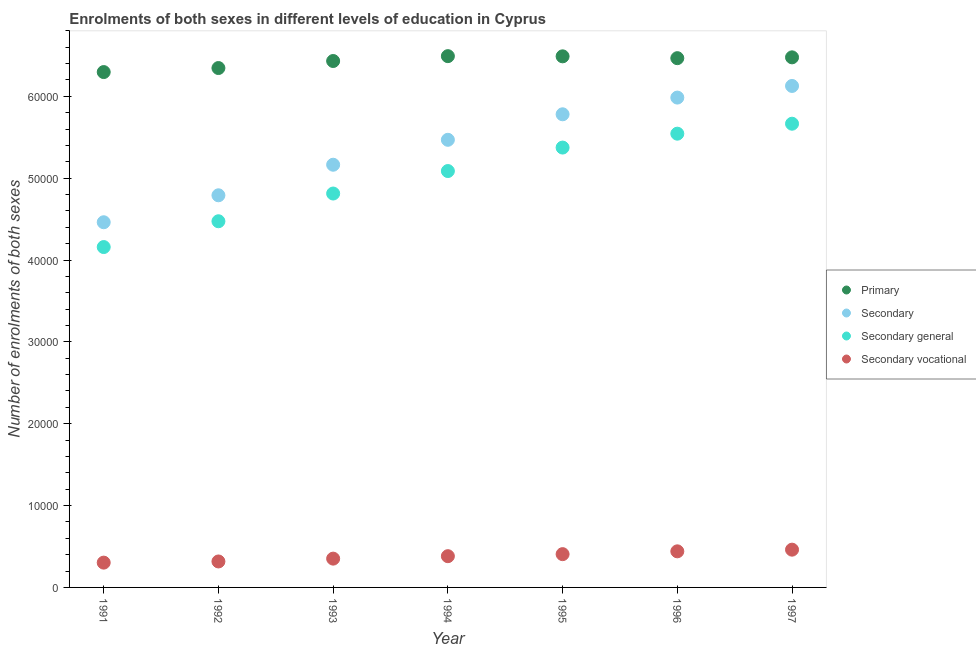What is the number of enrolments in secondary general education in 1996?
Your answer should be very brief. 5.54e+04. Across all years, what is the maximum number of enrolments in secondary vocational education?
Offer a terse response. 4614. Across all years, what is the minimum number of enrolments in secondary general education?
Make the answer very short. 4.16e+04. What is the total number of enrolments in secondary education in the graph?
Your response must be concise. 3.78e+05. What is the difference between the number of enrolments in secondary education in 1991 and that in 1992?
Give a very brief answer. -3294. What is the difference between the number of enrolments in secondary vocational education in 1994 and the number of enrolments in primary education in 1993?
Your answer should be compact. -6.05e+04. What is the average number of enrolments in primary education per year?
Provide a succinct answer. 6.43e+04. In the year 1997, what is the difference between the number of enrolments in primary education and number of enrolments in secondary vocational education?
Offer a terse response. 6.01e+04. In how many years, is the number of enrolments in secondary general education greater than 36000?
Provide a short and direct response. 7. What is the ratio of the number of enrolments in secondary general education in 1992 to that in 1994?
Offer a terse response. 0.88. Is the number of enrolments in primary education in 1995 less than that in 1997?
Your response must be concise. No. What is the difference between the highest and the second highest number of enrolments in secondary education?
Keep it short and to the point. 1421. What is the difference between the highest and the lowest number of enrolments in primary education?
Offer a terse response. 1945. In how many years, is the number of enrolments in primary education greater than the average number of enrolments in primary education taken over all years?
Offer a very short reply. 5. Is the sum of the number of enrolments in primary education in 1991 and 1992 greater than the maximum number of enrolments in secondary vocational education across all years?
Your answer should be compact. Yes. Is it the case that in every year, the sum of the number of enrolments in primary education and number of enrolments in secondary education is greater than the number of enrolments in secondary general education?
Keep it short and to the point. Yes. Is the number of enrolments in secondary vocational education strictly greater than the number of enrolments in primary education over the years?
Give a very brief answer. No. Is the number of enrolments in secondary education strictly less than the number of enrolments in primary education over the years?
Keep it short and to the point. Yes. What is the difference between two consecutive major ticks on the Y-axis?
Provide a short and direct response. 10000. Does the graph contain any zero values?
Your answer should be very brief. No. How are the legend labels stacked?
Provide a succinct answer. Vertical. What is the title of the graph?
Provide a succinct answer. Enrolments of both sexes in different levels of education in Cyprus. What is the label or title of the Y-axis?
Offer a very short reply. Number of enrolments of both sexes. What is the Number of enrolments of both sexes in Primary in 1991?
Offer a terse response. 6.30e+04. What is the Number of enrolments of both sexes in Secondary in 1991?
Your answer should be very brief. 4.46e+04. What is the Number of enrolments of both sexes of Secondary general in 1991?
Offer a very short reply. 4.16e+04. What is the Number of enrolments of both sexes of Secondary vocational in 1991?
Make the answer very short. 3030. What is the Number of enrolments of both sexes in Primary in 1992?
Offer a very short reply. 6.35e+04. What is the Number of enrolments of both sexes in Secondary in 1992?
Your answer should be compact. 4.79e+04. What is the Number of enrolments of both sexes in Secondary general in 1992?
Ensure brevity in your answer.  4.47e+04. What is the Number of enrolments of both sexes in Secondary vocational in 1992?
Your answer should be compact. 3172. What is the Number of enrolments of both sexes of Primary in 1993?
Offer a very short reply. 6.43e+04. What is the Number of enrolments of both sexes in Secondary in 1993?
Your answer should be compact. 5.16e+04. What is the Number of enrolments of both sexes in Secondary general in 1993?
Your answer should be very brief. 4.81e+04. What is the Number of enrolments of both sexes in Secondary vocational in 1993?
Ensure brevity in your answer.  3518. What is the Number of enrolments of both sexes in Primary in 1994?
Offer a terse response. 6.49e+04. What is the Number of enrolments of both sexes in Secondary in 1994?
Your response must be concise. 5.47e+04. What is the Number of enrolments of both sexes in Secondary general in 1994?
Offer a very short reply. 5.09e+04. What is the Number of enrolments of both sexes in Secondary vocational in 1994?
Your answer should be very brief. 3817. What is the Number of enrolments of both sexes in Primary in 1995?
Keep it short and to the point. 6.49e+04. What is the Number of enrolments of both sexes of Secondary in 1995?
Keep it short and to the point. 5.78e+04. What is the Number of enrolments of both sexes of Secondary general in 1995?
Your answer should be compact. 5.37e+04. What is the Number of enrolments of both sexes of Secondary vocational in 1995?
Offer a terse response. 4066. What is the Number of enrolments of both sexes in Primary in 1996?
Provide a short and direct response. 6.47e+04. What is the Number of enrolments of both sexes of Secondary in 1996?
Your answer should be very brief. 5.98e+04. What is the Number of enrolments of both sexes in Secondary general in 1996?
Keep it short and to the point. 5.54e+04. What is the Number of enrolments of both sexes of Secondary vocational in 1996?
Make the answer very short. 4410. What is the Number of enrolments of both sexes in Primary in 1997?
Provide a succinct answer. 6.48e+04. What is the Number of enrolments of both sexes in Secondary in 1997?
Your answer should be compact. 6.13e+04. What is the Number of enrolments of both sexes of Secondary general in 1997?
Your answer should be compact. 5.67e+04. What is the Number of enrolments of both sexes in Secondary vocational in 1997?
Your response must be concise. 4614. Across all years, what is the maximum Number of enrolments of both sexes in Primary?
Your answer should be compact. 6.49e+04. Across all years, what is the maximum Number of enrolments of both sexes in Secondary?
Offer a terse response. 6.13e+04. Across all years, what is the maximum Number of enrolments of both sexes in Secondary general?
Give a very brief answer. 5.67e+04. Across all years, what is the maximum Number of enrolments of both sexes in Secondary vocational?
Offer a very short reply. 4614. Across all years, what is the minimum Number of enrolments of both sexes of Primary?
Your response must be concise. 6.30e+04. Across all years, what is the minimum Number of enrolments of both sexes of Secondary?
Offer a very short reply. 4.46e+04. Across all years, what is the minimum Number of enrolments of both sexes in Secondary general?
Provide a short and direct response. 4.16e+04. Across all years, what is the minimum Number of enrolments of both sexes of Secondary vocational?
Provide a short and direct response. 3030. What is the total Number of enrolments of both sexes in Primary in the graph?
Ensure brevity in your answer.  4.50e+05. What is the total Number of enrolments of both sexes in Secondary in the graph?
Your response must be concise. 3.78e+05. What is the total Number of enrolments of both sexes of Secondary general in the graph?
Provide a succinct answer. 3.51e+05. What is the total Number of enrolments of both sexes of Secondary vocational in the graph?
Your answer should be compact. 2.66e+04. What is the difference between the Number of enrolments of both sexes in Primary in 1991 and that in 1992?
Make the answer very short. -492. What is the difference between the Number of enrolments of both sexes in Secondary in 1991 and that in 1992?
Keep it short and to the point. -3294. What is the difference between the Number of enrolments of both sexes in Secondary general in 1991 and that in 1992?
Make the answer very short. -3152. What is the difference between the Number of enrolments of both sexes of Secondary vocational in 1991 and that in 1992?
Keep it short and to the point. -142. What is the difference between the Number of enrolments of both sexes in Primary in 1991 and that in 1993?
Give a very brief answer. -1351. What is the difference between the Number of enrolments of both sexes in Secondary in 1991 and that in 1993?
Give a very brief answer. -7027. What is the difference between the Number of enrolments of both sexes in Secondary general in 1991 and that in 1993?
Ensure brevity in your answer.  -6539. What is the difference between the Number of enrolments of both sexes in Secondary vocational in 1991 and that in 1993?
Make the answer very short. -488. What is the difference between the Number of enrolments of both sexes in Primary in 1991 and that in 1994?
Give a very brief answer. -1945. What is the difference between the Number of enrolments of both sexes of Secondary in 1991 and that in 1994?
Your answer should be compact. -1.01e+04. What is the difference between the Number of enrolments of both sexes of Secondary general in 1991 and that in 1994?
Provide a succinct answer. -9286. What is the difference between the Number of enrolments of both sexes of Secondary vocational in 1991 and that in 1994?
Offer a very short reply. -787. What is the difference between the Number of enrolments of both sexes in Primary in 1991 and that in 1995?
Provide a succinct answer. -1922. What is the difference between the Number of enrolments of both sexes of Secondary in 1991 and that in 1995?
Keep it short and to the point. -1.32e+04. What is the difference between the Number of enrolments of both sexes in Secondary general in 1991 and that in 1995?
Offer a very short reply. -1.22e+04. What is the difference between the Number of enrolments of both sexes in Secondary vocational in 1991 and that in 1995?
Your response must be concise. -1036. What is the difference between the Number of enrolments of both sexes in Primary in 1991 and that in 1996?
Provide a short and direct response. -1698. What is the difference between the Number of enrolments of both sexes of Secondary in 1991 and that in 1996?
Your answer should be very brief. -1.52e+04. What is the difference between the Number of enrolments of both sexes of Secondary general in 1991 and that in 1996?
Make the answer very short. -1.39e+04. What is the difference between the Number of enrolments of both sexes in Secondary vocational in 1991 and that in 1996?
Ensure brevity in your answer.  -1380. What is the difference between the Number of enrolments of both sexes of Primary in 1991 and that in 1997?
Offer a very short reply. -1799. What is the difference between the Number of enrolments of both sexes of Secondary in 1991 and that in 1997?
Make the answer very short. -1.67e+04. What is the difference between the Number of enrolments of both sexes in Secondary general in 1991 and that in 1997?
Give a very brief answer. -1.51e+04. What is the difference between the Number of enrolments of both sexes in Secondary vocational in 1991 and that in 1997?
Provide a short and direct response. -1584. What is the difference between the Number of enrolments of both sexes of Primary in 1992 and that in 1993?
Your answer should be compact. -859. What is the difference between the Number of enrolments of both sexes in Secondary in 1992 and that in 1993?
Provide a short and direct response. -3733. What is the difference between the Number of enrolments of both sexes in Secondary general in 1992 and that in 1993?
Ensure brevity in your answer.  -3387. What is the difference between the Number of enrolments of both sexes of Secondary vocational in 1992 and that in 1993?
Provide a short and direct response. -346. What is the difference between the Number of enrolments of both sexes of Primary in 1992 and that in 1994?
Make the answer very short. -1453. What is the difference between the Number of enrolments of both sexes of Secondary in 1992 and that in 1994?
Provide a short and direct response. -6779. What is the difference between the Number of enrolments of both sexes in Secondary general in 1992 and that in 1994?
Ensure brevity in your answer.  -6134. What is the difference between the Number of enrolments of both sexes of Secondary vocational in 1992 and that in 1994?
Provide a succinct answer. -645. What is the difference between the Number of enrolments of both sexes in Primary in 1992 and that in 1995?
Offer a very short reply. -1430. What is the difference between the Number of enrolments of both sexes of Secondary in 1992 and that in 1995?
Your answer should be compact. -9896. What is the difference between the Number of enrolments of both sexes of Secondary general in 1992 and that in 1995?
Ensure brevity in your answer.  -9002. What is the difference between the Number of enrolments of both sexes of Secondary vocational in 1992 and that in 1995?
Your response must be concise. -894. What is the difference between the Number of enrolments of both sexes in Primary in 1992 and that in 1996?
Your answer should be compact. -1206. What is the difference between the Number of enrolments of both sexes of Secondary in 1992 and that in 1996?
Ensure brevity in your answer.  -1.19e+04. What is the difference between the Number of enrolments of both sexes in Secondary general in 1992 and that in 1996?
Your response must be concise. -1.07e+04. What is the difference between the Number of enrolments of both sexes in Secondary vocational in 1992 and that in 1996?
Provide a short and direct response. -1238. What is the difference between the Number of enrolments of both sexes of Primary in 1992 and that in 1997?
Make the answer very short. -1307. What is the difference between the Number of enrolments of both sexes in Secondary in 1992 and that in 1997?
Your answer should be compact. -1.34e+04. What is the difference between the Number of enrolments of both sexes of Secondary general in 1992 and that in 1997?
Ensure brevity in your answer.  -1.19e+04. What is the difference between the Number of enrolments of both sexes of Secondary vocational in 1992 and that in 1997?
Provide a short and direct response. -1442. What is the difference between the Number of enrolments of both sexes of Primary in 1993 and that in 1994?
Provide a succinct answer. -594. What is the difference between the Number of enrolments of both sexes in Secondary in 1993 and that in 1994?
Give a very brief answer. -3046. What is the difference between the Number of enrolments of both sexes of Secondary general in 1993 and that in 1994?
Offer a terse response. -2747. What is the difference between the Number of enrolments of both sexes in Secondary vocational in 1993 and that in 1994?
Give a very brief answer. -299. What is the difference between the Number of enrolments of both sexes of Primary in 1993 and that in 1995?
Provide a succinct answer. -571. What is the difference between the Number of enrolments of both sexes of Secondary in 1993 and that in 1995?
Your response must be concise. -6163. What is the difference between the Number of enrolments of both sexes of Secondary general in 1993 and that in 1995?
Give a very brief answer. -5615. What is the difference between the Number of enrolments of both sexes in Secondary vocational in 1993 and that in 1995?
Your response must be concise. -548. What is the difference between the Number of enrolments of both sexes in Primary in 1993 and that in 1996?
Give a very brief answer. -347. What is the difference between the Number of enrolments of both sexes in Secondary in 1993 and that in 1996?
Your answer should be compact. -8204. What is the difference between the Number of enrolments of both sexes in Secondary general in 1993 and that in 1996?
Offer a terse response. -7312. What is the difference between the Number of enrolments of both sexes of Secondary vocational in 1993 and that in 1996?
Your answer should be very brief. -892. What is the difference between the Number of enrolments of both sexes of Primary in 1993 and that in 1997?
Provide a succinct answer. -448. What is the difference between the Number of enrolments of both sexes in Secondary in 1993 and that in 1997?
Give a very brief answer. -9625. What is the difference between the Number of enrolments of both sexes of Secondary general in 1993 and that in 1997?
Your answer should be compact. -8529. What is the difference between the Number of enrolments of both sexes of Secondary vocational in 1993 and that in 1997?
Ensure brevity in your answer.  -1096. What is the difference between the Number of enrolments of both sexes in Primary in 1994 and that in 1995?
Provide a short and direct response. 23. What is the difference between the Number of enrolments of both sexes of Secondary in 1994 and that in 1995?
Give a very brief answer. -3117. What is the difference between the Number of enrolments of both sexes in Secondary general in 1994 and that in 1995?
Keep it short and to the point. -2868. What is the difference between the Number of enrolments of both sexes of Secondary vocational in 1994 and that in 1995?
Offer a very short reply. -249. What is the difference between the Number of enrolments of both sexes in Primary in 1994 and that in 1996?
Make the answer very short. 247. What is the difference between the Number of enrolments of both sexes in Secondary in 1994 and that in 1996?
Give a very brief answer. -5158. What is the difference between the Number of enrolments of both sexes of Secondary general in 1994 and that in 1996?
Provide a succinct answer. -4565. What is the difference between the Number of enrolments of both sexes in Secondary vocational in 1994 and that in 1996?
Offer a terse response. -593. What is the difference between the Number of enrolments of both sexes of Primary in 1994 and that in 1997?
Provide a succinct answer. 146. What is the difference between the Number of enrolments of both sexes in Secondary in 1994 and that in 1997?
Your answer should be compact. -6579. What is the difference between the Number of enrolments of both sexes of Secondary general in 1994 and that in 1997?
Your response must be concise. -5782. What is the difference between the Number of enrolments of both sexes in Secondary vocational in 1994 and that in 1997?
Provide a short and direct response. -797. What is the difference between the Number of enrolments of both sexes of Primary in 1995 and that in 1996?
Offer a terse response. 224. What is the difference between the Number of enrolments of both sexes in Secondary in 1995 and that in 1996?
Your response must be concise. -2041. What is the difference between the Number of enrolments of both sexes of Secondary general in 1995 and that in 1996?
Your answer should be very brief. -1697. What is the difference between the Number of enrolments of both sexes in Secondary vocational in 1995 and that in 1996?
Give a very brief answer. -344. What is the difference between the Number of enrolments of both sexes in Primary in 1995 and that in 1997?
Your answer should be very brief. 123. What is the difference between the Number of enrolments of both sexes of Secondary in 1995 and that in 1997?
Provide a short and direct response. -3462. What is the difference between the Number of enrolments of both sexes of Secondary general in 1995 and that in 1997?
Your response must be concise. -2914. What is the difference between the Number of enrolments of both sexes in Secondary vocational in 1995 and that in 1997?
Provide a succinct answer. -548. What is the difference between the Number of enrolments of both sexes in Primary in 1996 and that in 1997?
Keep it short and to the point. -101. What is the difference between the Number of enrolments of both sexes of Secondary in 1996 and that in 1997?
Provide a succinct answer. -1421. What is the difference between the Number of enrolments of both sexes in Secondary general in 1996 and that in 1997?
Provide a succinct answer. -1217. What is the difference between the Number of enrolments of both sexes in Secondary vocational in 1996 and that in 1997?
Offer a very short reply. -204. What is the difference between the Number of enrolments of both sexes in Primary in 1991 and the Number of enrolments of both sexes in Secondary in 1992?
Your response must be concise. 1.51e+04. What is the difference between the Number of enrolments of both sexes in Primary in 1991 and the Number of enrolments of both sexes in Secondary general in 1992?
Offer a very short reply. 1.82e+04. What is the difference between the Number of enrolments of both sexes in Primary in 1991 and the Number of enrolments of both sexes in Secondary vocational in 1992?
Your answer should be compact. 5.98e+04. What is the difference between the Number of enrolments of both sexes in Secondary in 1991 and the Number of enrolments of both sexes in Secondary general in 1992?
Your response must be concise. -122. What is the difference between the Number of enrolments of both sexes of Secondary in 1991 and the Number of enrolments of both sexes of Secondary vocational in 1992?
Your response must be concise. 4.14e+04. What is the difference between the Number of enrolments of both sexes in Secondary general in 1991 and the Number of enrolments of both sexes in Secondary vocational in 1992?
Your answer should be very brief. 3.84e+04. What is the difference between the Number of enrolments of both sexes in Primary in 1991 and the Number of enrolments of both sexes in Secondary in 1993?
Ensure brevity in your answer.  1.13e+04. What is the difference between the Number of enrolments of both sexes of Primary in 1991 and the Number of enrolments of both sexes of Secondary general in 1993?
Ensure brevity in your answer.  1.48e+04. What is the difference between the Number of enrolments of both sexes of Primary in 1991 and the Number of enrolments of both sexes of Secondary vocational in 1993?
Offer a very short reply. 5.94e+04. What is the difference between the Number of enrolments of both sexes of Secondary in 1991 and the Number of enrolments of both sexes of Secondary general in 1993?
Your answer should be very brief. -3509. What is the difference between the Number of enrolments of both sexes in Secondary in 1991 and the Number of enrolments of both sexes in Secondary vocational in 1993?
Keep it short and to the point. 4.11e+04. What is the difference between the Number of enrolments of both sexes in Secondary general in 1991 and the Number of enrolments of both sexes in Secondary vocational in 1993?
Provide a short and direct response. 3.81e+04. What is the difference between the Number of enrolments of both sexes in Primary in 1991 and the Number of enrolments of both sexes in Secondary in 1994?
Your answer should be compact. 8275. What is the difference between the Number of enrolments of both sexes in Primary in 1991 and the Number of enrolments of both sexes in Secondary general in 1994?
Keep it short and to the point. 1.21e+04. What is the difference between the Number of enrolments of both sexes in Primary in 1991 and the Number of enrolments of both sexes in Secondary vocational in 1994?
Offer a very short reply. 5.91e+04. What is the difference between the Number of enrolments of both sexes in Secondary in 1991 and the Number of enrolments of both sexes in Secondary general in 1994?
Give a very brief answer. -6256. What is the difference between the Number of enrolments of both sexes of Secondary in 1991 and the Number of enrolments of both sexes of Secondary vocational in 1994?
Provide a short and direct response. 4.08e+04. What is the difference between the Number of enrolments of both sexes in Secondary general in 1991 and the Number of enrolments of both sexes in Secondary vocational in 1994?
Your answer should be very brief. 3.78e+04. What is the difference between the Number of enrolments of both sexes in Primary in 1991 and the Number of enrolments of both sexes in Secondary in 1995?
Your response must be concise. 5158. What is the difference between the Number of enrolments of both sexes in Primary in 1991 and the Number of enrolments of both sexes in Secondary general in 1995?
Your response must be concise. 9224. What is the difference between the Number of enrolments of both sexes in Primary in 1991 and the Number of enrolments of both sexes in Secondary vocational in 1995?
Make the answer very short. 5.89e+04. What is the difference between the Number of enrolments of both sexes in Secondary in 1991 and the Number of enrolments of both sexes in Secondary general in 1995?
Offer a very short reply. -9124. What is the difference between the Number of enrolments of both sexes of Secondary in 1991 and the Number of enrolments of both sexes of Secondary vocational in 1995?
Make the answer very short. 4.05e+04. What is the difference between the Number of enrolments of both sexes of Secondary general in 1991 and the Number of enrolments of both sexes of Secondary vocational in 1995?
Your response must be concise. 3.75e+04. What is the difference between the Number of enrolments of both sexes of Primary in 1991 and the Number of enrolments of both sexes of Secondary in 1996?
Provide a succinct answer. 3117. What is the difference between the Number of enrolments of both sexes of Primary in 1991 and the Number of enrolments of both sexes of Secondary general in 1996?
Provide a succinct answer. 7527. What is the difference between the Number of enrolments of both sexes of Primary in 1991 and the Number of enrolments of both sexes of Secondary vocational in 1996?
Give a very brief answer. 5.86e+04. What is the difference between the Number of enrolments of both sexes of Secondary in 1991 and the Number of enrolments of both sexes of Secondary general in 1996?
Provide a short and direct response. -1.08e+04. What is the difference between the Number of enrolments of both sexes of Secondary in 1991 and the Number of enrolments of both sexes of Secondary vocational in 1996?
Give a very brief answer. 4.02e+04. What is the difference between the Number of enrolments of both sexes of Secondary general in 1991 and the Number of enrolments of both sexes of Secondary vocational in 1996?
Keep it short and to the point. 3.72e+04. What is the difference between the Number of enrolments of both sexes in Primary in 1991 and the Number of enrolments of both sexes in Secondary in 1997?
Offer a very short reply. 1696. What is the difference between the Number of enrolments of both sexes of Primary in 1991 and the Number of enrolments of both sexes of Secondary general in 1997?
Keep it short and to the point. 6310. What is the difference between the Number of enrolments of both sexes of Primary in 1991 and the Number of enrolments of both sexes of Secondary vocational in 1997?
Provide a succinct answer. 5.83e+04. What is the difference between the Number of enrolments of both sexes in Secondary in 1991 and the Number of enrolments of both sexes in Secondary general in 1997?
Give a very brief answer. -1.20e+04. What is the difference between the Number of enrolments of both sexes in Secondary general in 1991 and the Number of enrolments of both sexes in Secondary vocational in 1997?
Keep it short and to the point. 3.70e+04. What is the difference between the Number of enrolments of both sexes in Primary in 1992 and the Number of enrolments of both sexes in Secondary in 1993?
Give a very brief answer. 1.18e+04. What is the difference between the Number of enrolments of both sexes in Primary in 1992 and the Number of enrolments of both sexes in Secondary general in 1993?
Your response must be concise. 1.53e+04. What is the difference between the Number of enrolments of both sexes in Primary in 1992 and the Number of enrolments of both sexes in Secondary vocational in 1993?
Offer a very short reply. 5.99e+04. What is the difference between the Number of enrolments of both sexes in Secondary in 1992 and the Number of enrolments of both sexes in Secondary general in 1993?
Keep it short and to the point. -215. What is the difference between the Number of enrolments of both sexes in Secondary in 1992 and the Number of enrolments of both sexes in Secondary vocational in 1993?
Make the answer very short. 4.44e+04. What is the difference between the Number of enrolments of both sexes in Secondary general in 1992 and the Number of enrolments of both sexes in Secondary vocational in 1993?
Give a very brief answer. 4.12e+04. What is the difference between the Number of enrolments of both sexes in Primary in 1992 and the Number of enrolments of both sexes in Secondary in 1994?
Your answer should be compact. 8767. What is the difference between the Number of enrolments of both sexes in Primary in 1992 and the Number of enrolments of both sexes in Secondary general in 1994?
Give a very brief answer. 1.26e+04. What is the difference between the Number of enrolments of both sexes of Primary in 1992 and the Number of enrolments of both sexes of Secondary vocational in 1994?
Keep it short and to the point. 5.96e+04. What is the difference between the Number of enrolments of both sexes in Secondary in 1992 and the Number of enrolments of both sexes in Secondary general in 1994?
Provide a short and direct response. -2962. What is the difference between the Number of enrolments of both sexes of Secondary in 1992 and the Number of enrolments of both sexes of Secondary vocational in 1994?
Make the answer very short. 4.41e+04. What is the difference between the Number of enrolments of both sexes of Secondary general in 1992 and the Number of enrolments of both sexes of Secondary vocational in 1994?
Ensure brevity in your answer.  4.09e+04. What is the difference between the Number of enrolments of both sexes in Primary in 1992 and the Number of enrolments of both sexes in Secondary in 1995?
Offer a terse response. 5650. What is the difference between the Number of enrolments of both sexes of Primary in 1992 and the Number of enrolments of both sexes of Secondary general in 1995?
Make the answer very short. 9716. What is the difference between the Number of enrolments of both sexes in Primary in 1992 and the Number of enrolments of both sexes in Secondary vocational in 1995?
Give a very brief answer. 5.94e+04. What is the difference between the Number of enrolments of both sexes in Secondary in 1992 and the Number of enrolments of both sexes in Secondary general in 1995?
Provide a short and direct response. -5830. What is the difference between the Number of enrolments of both sexes of Secondary in 1992 and the Number of enrolments of both sexes of Secondary vocational in 1995?
Provide a short and direct response. 4.38e+04. What is the difference between the Number of enrolments of both sexes of Secondary general in 1992 and the Number of enrolments of both sexes of Secondary vocational in 1995?
Your answer should be very brief. 4.07e+04. What is the difference between the Number of enrolments of both sexes in Primary in 1992 and the Number of enrolments of both sexes in Secondary in 1996?
Keep it short and to the point. 3609. What is the difference between the Number of enrolments of both sexes in Primary in 1992 and the Number of enrolments of both sexes in Secondary general in 1996?
Give a very brief answer. 8019. What is the difference between the Number of enrolments of both sexes in Primary in 1992 and the Number of enrolments of both sexes in Secondary vocational in 1996?
Offer a very short reply. 5.90e+04. What is the difference between the Number of enrolments of both sexes of Secondary in 1992 and the Number of enrolments of both sexes of Secondary general in 1996?
Keep it short and to the point. -7527. What is the difference between the Number of enrolments of both sexes in Secondary in 1992 and the Number of enrolments of both sexes in Secondary vocational in 1996?
Your answer should be very brief. 4.35e+04. What is the difference between the Number of enrolments of both sexes of Secondary general in 1992 and the Number of enrolments of both sexes of Secondary vocational in 1996?
Your response must be concise. 4.03e+04. What is the difference between the Number of enrolments of both sexes in Primary in 1992 and the Number of enrolments of both sexes in Secondary in 1997?
Make the answer very short. 2188. What is the difference between the Number of enrolments of both sexes of Primary in 1992 and the Number of enrolments of both sexes of Secondary general in 1997?
Your answer should be very brief. 6802. What is the difference between the Number of enrolments of both sexes in Primary in 1992 and the Number of enrolments of both sexes in Secondary vocational in 1997?
Offer a terse response. 5.88e+04. What is the difference between the Number of enrolments of both sexes of Secondary in 1992 and the Number of enrolments of both sexes of Secondary general in 1997?
Provide a short and direct response. -8744. What is the difference between the Number of enrolments of both sexes in Secondary in 1992 and the Number of enrolments of both sexes in Secondary vocational in 1997?
Give a very brief answer. 4.33e+04. What is the difference between the Number of enrolments of both sexes in Secondary general in 1992 and the Number of enrolments of both sexes in Secondary vocational in 1997?
Your answer should be very brief. 4.01e+04. What is the difference between the Number of enrolments of both sexes of Primary in 1993 and the Number of enrolments of both sexes of Secondary in 1994?
Your answer should be very brief. 9626. What is the difference between the Number of enrolments of both sexes of Primary in 1993 and the Number of enrolments of both sexes of Secondary general in 1994?
Provide a succinct answer. 1.34e+04. What is the difference between the Number of enrolments of both sexes of Primary in 1993 and the Number of enrolments of both sexes of Secondary vocational in 1994?
Make the answer very short. 6.05e+04. What is the difference between the Number of enrolments of both sexes of Secondary in 1993 and the Number of enrolments of both sexes of Secondary general in 1994?
Keep it short and to the point. 771. What is the difference between the Number of enrolments of both sexes in Secondary in 1993 and the Number of enrolments of both sexes in Secondary vocational in 1994?
Keep it short and to the point. 4.78e+04. What is the difference between the Number of enrolments of both sexes in Secondary general in 1993 and the Number of enrolments of both sexes in Secondary vocational in 1994?
Offer a terse response. 4.43e+04. What is the difference between the Number of enrolments of both sexes of Primary in 1993 and the Number of enrolments of both sexes of Secondary in 1995?
Your response must be concise. 6509. What is the difference between the Number of enrolments of both sexes of Primary in 1993 and the Number of enrolments of both sexes of Secondary general in 1995?
Your response must be concise. 1.06e+04. What is the difference between the Number of enrolments of both sexes of Primary in 1993 and the Number of enrolments of both sexes of Secondary vocational in 1995?
Offer a very short reply. 6.02e+04. What is the difference between the Number of enrolments of both sexes of Secondary in 1993 and the Number of enrolments of both sexes of Secondary general in 1995?
Ensure brevity in your answer.  -2097. What is the difference between the Number of enrolments of both sexes in Secondary in 1993 and the Number of enrolments of both sexes in Secondary vocational in 1995?
Provide a short and direct response. 4.76e+04. What is the difference between the Number of enrolments of both sexes in Secondary general in 1993 and the Number of enrolments of both sexes in Secondary vocational in 1995?
Keep it short and to the point. 4.41e+04. What is the difference between the Number of enrolments of both sexes in Primary in 1993 and the Number of enrolments of both sexes in Secondary in 1996?
Your answer should be very brief. 4468. What is the difference between the Number of enrolments of both sexes in Primary in 1993 and the Number of enrolments of both sexes in Secondary general in 1996?
Provide a succinct answer. 8878. What is the difference between the Number of enrolments of both sexes in Primary in 1993 and the Number of enrolments of both sexes in Secondary vocational in 1996?
Offer a very short reply. 5.99e+04. What is the difference between the Number of enrolments of both sexes in Secondary in 1993 and the Number of enrolments of both sexes in Secondary general in 1996?
Make the answer very short. -3794. What is the difference between the Number of enrolments of both sexes of Secondary in 1993 and the Number of enrolments of both sexes of Secondary vocational in 1996?
Keep it short and to the point. 4.72e+04. What is the difference between the Number of enrolments of both sexes of Secondary general in 1993 and the Number of enrolments of both sexes of Secondary vocational in 1996?
Make the answer very short. 4.37e+04. What is the difference between the Number of enrolments of both sexes in Primary in 1993 and the Number of enrolments of both sexes in Secondary in 1997?
Provide a short and direct response. 3047. What is the difference between the Number of enrolments of both sexes of Primary in 1993 and the Number of enrolments of both sexes of Secondary general in 1997?
Offer a terse response. 7661. What is the difference between the Number of enrolments of both sexes in Primary in 1993 and the Number of enrolments of both sexes in Secondary vocational in 1997?
Give a very brief answer. 5.97e+04. What is the difference between the Number of enrolments of both sexes of Secondary in 1993 and the Number of enrolments of both sexes of Secondary general in 1997?
Offer a terse response. -5011. What is the difference between the Number of enrolments of both sexes in Secondary in 1993 and the Number of enrolments of both sexes in Secondary vocational in 1997?
Keep it short and to the point. 4.70e+04. What is the difference between the Number of enrolments of both sexes in Secondary general in 1993 and the Number of enrolments of both sexes in Secondary vocational in 1997?
Give a very brief answer. 4.35e+04. What is the difference between the Number of enrolments of both sexes of Primary in 1994 and the Number of enrolments of both sexes of Secondary in 1995?
Your response must be concise. 7103. What is the difference between the Number of enrolments of both sexes in Primary in 1994 and the Number of enrolments of both sexes in Secondary general in 1995?
Your response must be concise. 1.12e+04. What is the difference between the Number of enrolments of both sexes of Primary in 1994 and the Number of enrolments of both sexes of Secondary vocational in 1995?
Offer a very short reply. 6.08e+04. What is the difference between the Number of enrolments of both sexes of Secondary in 1994 and the Number of enrolments of both sexes of Secondary general in 1995?
Give a very brief answer. 949. What is the difference between the Number of enrolments of both sexes in Secondary in 1994 and the Number of enrolments of both sexes in Secondary vocational in 1995?
Your answer should be compact. 5.06e+04. What is the difference between the Number of enrolments of both sexes of Secondary general in 1994 and the Number of enrolments of both sexes of Secondary vocational in 1995?
Your response must be concise. 4.68e+04. What is the difference between the Number of enrolments of both sexes of Primary in 1994 and the Number of enrolments of both sexes of Secondary in 1996?
Offer a terse response. 5062. What is the difference between the Number of enrolments of both sexes in Primary in 1994 and the Number of enrolments of both sexes in Secondary general in 1996?
Make the answer very short. 9472. What is the difference between the Number of enrolments of both sexes in Primary in 1994 and the Number of enrolments of both sexes in Secondary vocational in 1996?
Keep it short and to the point. 6.05e+04. What is the difference between the Number of enrolments of both sexes of Secondary in 1994 and the Number of enrolments of both sexes of Secondary general in 1996?
Make the answer very short. -748. What is the difference between the Number of enrolments of both sexes in Secondary in 1994 and the Number of enrolments of both sexes in Secondary vocational in 1996?
Ensure brevity in your answer.  5.03e+04. What is the difference between the Number of enrolments of both sexes of Secondary general in 1994 and the Number of enrolments of both sexes of Secondary vocational in 1996?
Your answer should be very brief. 4.65e+04. What is the difference between the Number of enrolments of both sexes of Primary in 1994 and the Number of enrolments of both sexes of Secondary in 1997?
Provide a short and direct response. 3641. What is the difference between the Number of enrolments of both sexes of Primary in 1994 and the Number of enrolments of both sexes of Secondary general in 1997?
Provide a short and direct response. 8255. What is the difference between the Number of enrolments of both sexes in Primary in 1994 and the Number of enrolments of both sexes in Secondary vocational in 1997?
Give a very brief answer. 6.03e+04. What is the difference between the Number of enrolments of both sexes in Secondary in 1994 and the Number of enrolments of both sexes in Secondary general in 1997?
Ensure brevity in your answer.  -1965. What is the difference between the Number of enrolments of both sexes in Secondary in 1994 and the Number of enrolments of both sexes in Secondary vocational in 1997?
Keep it short and to the point. 5.01e+04. What is the difference between the Number of enrolments of both sexes in Secondary general in 1994 and the Number of enrolments of both sexes in Secondary vocational in 1997?
Give a very brief answer. 4.63e+04. What is the difference between the Number of enrolments of both sexes of Primary in 1995 and the Number of enrolments of both sexes of Secondary in 1996?
Give a very brief answer. 5039. What is the difference between the Number of enrolments of both sexes of Primary in 1995 and the Number of enrolments of both sexes of Secondary general in 1996?
Your answer should be very brief. 9449. What is the difference between the Number of enrolments of both sexes in Primary in 1995 and the Number of enrolments of both sexes in Secondary vocational in 1996?
Give a very brief answer. 6.05e+04. What is the difference between the Number of enrolments of both sexes in Secondary in 1995 and the Number of enrolments of both sexes in Secondary general in 1996?
Provide a succinct answer. 2369. What is the difference between the Number of enrolments of both sexes of Secondary in 1995 and the Number of enrolments of both sexes of Secondary vocational in 1996?
Ensure brevity in your answer.  5.34e+04. What is the difference between the Number of enrolments of both sexes of Secondary general in 1995 and the Number of enrolments of both sexes of Secondary vocational in 1996?
Give a very brief answer. 4.93e+04. What is the difference between the Number of enrolments of both sexes in Primary in 1995 and the Number of enrolments of both sexes in Secondary in 1997?
Provide a succinct answer. 3618. What is the difference between the Number of enrolments of both sexes in Primary in 1995 and the Number of enrolments of both sexes in Secondary general in 1997?
Give a very brief answer. 8232. What is the difference between the Number of enrolments of both sexes in Primary in 1995 and the Number of enrolments of both sexes in Secondary vocational in 1997?
Make the answer very short. 6.03e+04. What is the difference between the Number of enrolments of both sexes in Secondary in 1995 and the Number of enrolments of both sexes in Secondary general in 1997?
Your answer should be compact. 1152. What is the difference between the Number of enrolments of both sexes of Secondary in 1995 and the Number of enrolments of both sexes of Secondary vocational in 1997?
Offer a terse response. 5.32e+04. What is the difference between the Number of enrolments of both sexes in Secondary general in 1995 and the Number of enrolments of both sexes in Secondary vocational in 1997?
Your answer should be very brief. 4.91e+04. What is the difference between the Number of enrolments of both sexes of Primary in 1996 and the Number of enrolments of both sexes of Secondary in 1997?
Offer a very short reply. 3394. What is the difference between the Number of enrolments of both sexes in Primary in 1996 and the Number of enrolments of both sexes in Secondary general in 1997?
Your answer should be compact. 8008. What is the difference between the Number of enrolments of both sexes of Primary in 1996 and the Number of enrolments of both sexes of Secondary vocational in 1997?
Offer a very short reply. 6.00e+04. What is the difference between the Number of enrolments of both sexes of Secondary in 1996 and the Number of enrolments of both sexes of Secondary general in 1997?
Make the answer very short. 3193. What is the difference between the Number of enrolments of both sexes of Secondary in 1996 and the Number of enrolments of both sexes of Secondary vocational in 1997?
Keep it short and to the point. 5.52e+04. What is the difference between the Number of enrolments of both sexes in Secondary general in 1996 and the Number of enrolments of both sexes in Secondary vocational in 1997?
Ensure brevity in your answer.  5.08e+04. What is the average Number of enrolments of both sexes of Primary per year?
Provide a short and direct response. 6.43e+04. What is the average Number of enrolments of both sexes of Secondary per year?
Ensure brevity in your answer.  5.40e+04. What is the average Number of enrolments of both sexes of Secondary general per year?
Keep it short and to the point. 5.02e+04. What is the average Number of enrolments of both sexes of Secondary vocational per year?
Your response must be concise. 3803.86. In the year 1991, what is the difference between the Number of enrolments of both sexes in Primary and Number of enrolments of both sexes in Secondary?
Keep it short and to the point. 1.83e+04. In the year 1991, what is the difference between the Number of enrolments of both sexes in Primary and Number of enrolments of both sexes in Secondary general?
Provide a succinct answer. 2.14e+04. In the year 1991, what is the difference between the Number of enrolments of both sexes in Primary and Number of enrolments of both sexes in Secondary vocational?
Make the answer very short. 5.99e+04. In the year 1991, what is the difference between the Number of enrolments of both sexes in Secondary and Number of enrolments of both sexes in Secondary general?
Your response must be concise. 3030. In the year 1991, what is the difference between the Number of enrolments of both sexes of Secondary and Number of enrolments of both sexes of Secondary vocational?
Your answer should be very brief. 4.16e+04. In the year 1991, what is the difference between the Number of enrolments of both sexes of Secondary general and Number of enrolments of both sexes of Secondary vocational?
Provide a succinct answer. 3.86e+04. In the year 1992, what is the difference between the Number of enrolments of both sexes in Primary and Number of enrolments of both sexes in Secondary?
Your answer should be very brief. 1.55e+04. In the year 1992, what is the difference between the Number of enrolments of both sexes in Primary and Number of enrolments of both sexes in Secondary general?
Make the answer very short. 1.87e+04. In the year 1992, what is the difference between the Number of enrolments of both sexes of Primary and Number of enrolments of both sexes of Secondary vocational?
Your answer should be compact. 6.03e+04. In the year 1992, what is the difference between the Number of enrolments of both sexes in Secondary and Number of enrolments of both sexes in Secondary general?
Make the answer very short. 3172. In the year 1992, what is the difference between the Number of enrolments of both sexes of Secondary and Number of enrolments of both sexes of Secondary vocational?
Make the answer very short. 4.47e+04. In the year 1992, what is the difference between the Number of enrolments of both sexes in Secondary general and Number of enrolments of both sexes in Secondary vocational?
Your answer should be very brief. 4.16e+04. In the year 1993, what is the difference between the Number of enrolments of both sexes in Primary and Number of enrolments of both sexes in Secondary?
Offer a very short reply. 1.27e+04. In the year 1993, what is the difference between the Number of enrolments of both sexes in Primary and Number of enrolments of both sexes in Secondary general?
Give a very brief answer. 1.62e+04. In the year 1993, what is the difference between the Number of enrolments of both sexes in Primary and Number of enrolments of both sexes in Secondary vocational?
Keep it short and to the point. 6.08e+04. In the year 1993, what is the difference between the Number of enrolments of both sexes of Secondary and Number of enrolments of both sexes of Secondary general?
Provide a short and direct response. 3518. In the year 1993, what is the difference between the Number of enrolments of both sexes in Secondary and Number of enrolments of both sexes in Secondary vocational?
Your answer should be compact. 4.81e+04. In the year 1993, what is the difference between the Number of enrolments of both sexes of Secondary general and Number of enrolments of both sexes of Secondary vocational?
Your response must be concise. 4.46e+04. In the year 1994, what is the difference between the Number of enrolments of both sexes in Primary and Number of enrolments of both sexes in Secondary?
Your answer should be compact. 1.02e+04. In the year 1994, what is the difference between the Number of enrolments of both sexes in Primary and Number of enrolments of both sexes in Secondary general?
Give a very brief answer. 1.40e+04. In the year 1994, what is the difference between the Number of enrolments of both sexes of Primary and Number of enrolments of both sexes of Secondary vocational?
Provide a short and direct response. 6.11e+04. In the year 1994, what is the difference between the Number of enrolments of both sexes of Secondary and Number of enrolments of both sexes of Secondary general?
Give a very brief answer. 3817. In the year 1994, what is the difference between the Number of enrolments of both sexes in Secondary and Number of enrolments of both sexes in Secondary vocational?
Your answer should be compact. 5.09e+04. In the year 1994, what is the difference between the Number of enrolments of both sexes of Secondary general and Number of enrolments of both sexes of Secondary vocational?
Offer a very short reply. 4.71e+04. In the year 1995, what is the difference between the Number of enrolments of both sexes of Primary and Number of enrolments of both sexes of Secondary?
Offer a terse response. 7080. In the year 1995, what is the difference between the Number of enrolments of both sexes in Primary and Number of enrolments of both sexes in Secondary general?
Your response must be concise. 1.11e+04. In the year 1995, what is the difference between the Number of enrolments of both sexes of Primary and Number of enrolments of both sexes of Secondary vocational?
Your answer should be compact. 6.08e+04. In the year 1995, what is the difference between the Number of enrolments of both sexes of Secondary and Number of enrolments of both sexes of Secondary general?
Make the answer very short. 4066. In the year 1995, what is the difference between the Number of enrolments of both sexes of Secondary and Number of enrolments of both sexes of Secondary vocational?
Your answer should be compact. 5.37e+04. In the year 1995, what is the difference between the Number of enrolments of both sexes in Secondary general and Number of enrolments of both sexes in Secondary vocational?
Provide a short and direct response. 4.97e+04. In the year 1996, what is the difference between the Number of enrolments of both sexes in Primary and Number of enrolments of both sexes in Secondary?
Your answer should be very brief. 4815. In the year 1996, what is the difference between the Number of enrolments of both sexes of Primary and Number of enrolments of both sexes of Secondary general?
Provide a short and direct response. 9225. In the year 1996, what is the difference between the Number of enrolments of both sexes of Primary and Number of enrolments of both sexes of Secondary vocational?
Provide a short and direct response. 6.02e+04. In the year 1996, what is the difference between the Number of enrolments of both sexes in Secondary and Number of enrolments of both sexes in Secondary general?
Give a very brief answer. 4410. In the year 1996, what is the difference between the Number of enrolments of both sexes of Secondary and Number of enrolments of both sexes of Secondary vocational?
Your answer should be compact. 5.54e+04. In the year 1996, what is the difference between the Number of enrolments of both sexes of Secondary general and Number of enrolments of both sexes of Secondary vocational?
Offer a terse response. 5.10e+04. In the year 1997, what is the difference between the Number of enrolments of both sexes in Primary and Number of enrolments of both sexes in Secondary?
Your answer should be very brief. 3495. In the year 1997, what is the difference between the Number of enrolments of both sexes in Primary and Number of enrolments of both sexes in Secondary general?
Your answer should be compact. 8109. In the year 1997, what is the difference between the Number of enrolments of both sexes of Primary and Number of enrolments of both sexes of Secondary vocational?
Provide a succinct answer. 6.01e+04. In the year 1997, what is the difference between the Number of enrolments of both sexes of Secondary and Number of enrolments of both sexes of Secondary general?
Your response must be concise. 4614. In the year 1997, what is the difference between the Number of enrolments of both sexes of Secondary and Number of enrolments of both sexes of Secondary vocational?
Your answer should be very brief. 5.67e+04. In the year 1997, what is the difference between the Number of enrolments of both sexes in Secondary general and Number of enrolments of both sexes in Secondary vocational?
Make the answer very short. 5.20e+04. What is the ratio of the Number of enrolments of both sexes of Secondary in 1991 to that in 1992?
Ensure brevity in your answer.  0.93. What is the ratio of the Number of enrolments of both sexes of Secondary general in 1991 to that in 1992?
Provide a short and direct response. 0.93. What is the ratio of the Number of enrolments of both sexes in Secondary vocational in 1991 to that in 1992?
Keep it short and to the point. 0.96. What is the ratio of the Number of enrolments of both sexes of Primary in 1991 to that in 1993?
Make the answer very short. 0.98. What is the ratio of the Number of enrolments of both sexes in Secondary in 1991 to that in 1993?
Your answer should be very brief. 0.86. What is the ratio of the Number of enrolments of both sexes in Secondary general in 1991 to that in 1993?
Keep it short and to the point. 0.86. What is the ratio of the Number of enrolments of both sexes of Secondary vocational in 1991 to that in 1993?
Make the answer very short. 0.86. What is the ratio of the Number of enrolments of both sexes in Primary in 1991 to that in 1994?
Your answer should be very brief. 0.97. What is the ratio of the Number of enrolments of both sexes of Secondary in 1991 to that in 1994?
Give a very brief answer. 0.82. What is the ratio of the Number of enrolments of both sexes of Secondary general in 1991 to that in 1994?
Offer a terse response. 0.82. What is the ratio of the Number of enrolments of both sexes of Secondary vocational in 1991 to that in 1994?
Your answer should be very brief. 0.79. What is the ratio of the Number of enrolments of both sexes of Primary in 1991 to that in 1995?
Your answer should be compact. 0.97. What is the ratio of the Number of enrolments of both sexes of Secondary in 1991 to that in 1995?
Your response must be concise. 0.77. What is the ratio of the Number of enrolments of both sexes of Secondary general in 1991 to that in 1995?
Give a very brief answer. 0.77. What is the ratio of the Number of enrolments of both sexes in Secondary vocational in 1991 to that in 1995?
Ensure brevity in your answer.  0.75. What is the ratio of the Number of enrolments of both sexes of Primary in 1991 to that in 1996?
Your answer should be very brief. 0.97. What is the ratio of the Number of enrolments of both sexes in Secondary in 1991 to that in 1996?
Offer a terse response. 0.75. What is the ratio of the Number of enrolments of both sexes of Secondary general in 1991 to that in 1996?
Make the answer very short. 0.75. What is the ratio of the Number of enrolments of both sexes of Secondary vocational in 1991 to that in 1996?
Give a very brief answer. 0.69. What is the ratio of the Number of enrolments of both sexes of Primary in 1991 to that in 1997?
Give a very brief answer. 0.97. What is the ratio of the Number of enrolments of both sexes of Secondary in 1991 to that in 1997?
Your response must be concise. 0.73. What is the ratio of the Number of enrolments of both sexes of Secondary general in 1991 to that in 1997?
Provide a short and direct response. 0.73. What is the ratio of the Number of enrolments of both sexes in Secondary vocational in 1991 to that in 1997?
Provide a short and direct response. 0.66. What is the ratio of the Number of enrolments of both sexes of Primary in 1992 to that in 1993?
Make the answer very short. 0.99. What is the ratio of the Number of enrolments of both sexes of Secondary in 1992 to that in 1993?
Your answer should be compact. 0.93. What is the ratio of the Number of enrolments of both sexes of Secondary general in 1992 to that in 1993?
Give a very brief answer. 0.93. What is the ratio of the Number of enrolments of both sexes of Secondary vocational in 1992 to that in 1993?
Your answer should be compact. 0.9. What is the ratio of the Number of enrolments of both sexes of Primary in 1992 to that in 1994?
Ensure brevity in your answer.  0.98. What is the ratio of the Number of enrolments of both sexes in Secondary in 1992 to that in 1994?
Your answer should be compact. 0.88. What is the ratio of the Number of enrolments of both sexes in Secondary general in 1992 to that in 1994?
Offer a very short reply. 0.88. What is the ratio of the Number of enrolments of both sexes of Secondary vocational in 1992 to that in 1994?
Make the answer very short. 0.83. What is the ratio of the Number of enrolments of both sexes of Secondary in 1992 to that in 1995?
Keep it short and to the point. 0.83. What is the ratio of the Number of enrolments of both sexes of Secondary general in 1992 to that in 1995?
Keep it short and to the point. 0.83. What is the ratio of the Number of enrolments of both sexes in Secondary vocational in 1992 to that in 1995?
Your answer should be compact. 0.78. What is the ratio of the Number of enrolments of both sexes in Primary in 1992 to that in 1996?
Ensure brevity in your answer.  0.98. What is the ratio of the Number of enrolments of both sexes in Secondary in 1992 to that in 1996?
Offer a very short reply. 0.8. What is the ratio of the Number of enrolments of both sexes in Secondary general in 1992 to that in 1996?
Offer a terse response. 0.81. What is the ratio of the Number of enrolments of both sexes of Secondary vocational in 1992 to that in 1996?
Your response must be concise. 0.72. What is the ratio of the Number of enrolments of both sexes in Primary in 1992 to that in 1997?
Your answer should be compact. 0.98. What is the ratio of the Number of enrolments of both sexes in Secondary in 1992 to that in 1997?
Give a very brief answer. 0.78. What is the ratio of the Number of enrolments of both sexes in Secondary general in 1992 to that in 1997?
Make the answer very short. 0.79. What is the ratio of the Number of enrolments of both sexes of Secondary vocational in 1992 to that in 1997?
Your answer should be very brief. 0.69. What is the ratio of the Number of enrolments of both sexes of Primary in 1993 to that in 1994?
Keep it short and to the point. 0.99. What is the ratio of the Number of enrolments of both sexes of Secondary in 1993 to that in 1994?
Offer a very short reply. 0.94. What is the ratio of the Number of enrolments of both sexes of Secondary general in 1993 to that in 1994?
Provide a succinct answer. 0.95. What is the ratio of the Number of enrolments of both sexes of Secondary vocational in 1993 to that in 1994?
Offer a terse response. 0.92. What is the ratio of the Number of enrolments of both sexes of Secondary in 1993 to that in 1995?
Your response must be concise. 0.89. What is the ratio of the Number of enrolments of both sexes in Secondary general in 1993 to that in 1995?
Offer a very short reply. 0.9. What is the ratio of the Number of enrolments of both sexes in Secondary vocational in 1993 to that in 1995?
Your answer should be compact. 0.87. What is the ratio of the Number of enrolments of both sexes in Secondary in 1993 to that in 1996?
Give a very brief answer. 0.86. What is the ratio of the Number of enrolments of both sexes of Secondary general in 1993 to that in 1996?
Your response must be concise. 0.87. What is the ratio of the Number of enrolments of both sexes of Secondary vocational in 1993 to that in 1996?
Provide a short and direct response. 0.8. What is the ratio of the Number of enrolments of both sexes of Secondary in 1993 to that in 1997?
Your answer should be compact. 0.84. What is the ratio of the Number of enrolments of both sexes of Secondary general in 1993 to that in 1997?
Offer a terse response. 0.85. What is the ratio of the Number of enrolments of both sexes in Secondary vocational in 1993 to that in 1997?
Provide a short and direct response. 0.76. What is the ratio of the Number of enrolments of both sexes of Primary in 1994 to that in 1995?
Offer a very short reply. 1. What is the ratio of the Number of enrolments of both sexes in Secondary in 1994 to that in 1995?
Keep it short and to the point. 0.95. What is the ratio of the Number of enrolments of both sexes in Secondary general in 1994 to that in 1995?
Give a very brief answer. 0.95. What is the ratio of the Number of enrolments of both sexes in Secondary vocational in 1994 to that in 1995?
Ensure brevity in your answer.  0.94. What is the ratio of the Number of enrolments of both sexes of Secondary in 1994 to that in 1996?
Your response must be concise. 0.91. What is the ratio of the Number of enrolments of both sexes of Secondary general in 1994 to that in 1996?
Provide a short and direct response. 0.92. What is the ratio of the Number of enrolments of both sexes of Secondary vocational in 1994 to that in 1996?
Make the answer very short. 0.87. What is the ratio of the Number of enrolments of both sexes in Secondary in 1994 to that in 1997?
Provide a short and direct response. 0.89. What is the ratio of the Number of enrolments of both sexes in Secondary general in 1994 to that in 1997?
Offer a very short reply. 0.9. What is the ratio of the Number of enrolments of both sexes of Secondary vocational in 1994 to that in 1997?
Your response must be concise. 0.83. What is the ratio of the Number of enrolments of both sexes of Secondary in 1995 to that in 1996?
Make the answer very short. 0.97. What is the ratio of the Number of enrolments of both sexes in Secondary general in 1995 to that in 1996?
Make the answer very short. 0.97. What is the ratio of the Number of enrolments of both sexes in Secondary vocational in 1995 to that in 1996?
Provide a short and direct response. 0.92. What is the ratio of the Number of enrolments of both sexes of Primary in 1995 to that in 1997?
Your answer should be compact. 1. What is the ratio of the Number of enrolments of both sexes of Secondary in 1995 to that in 1997?
Ensure brevity in your answer.  0.94. What is the ratio of the Number of enrolments of both sexes of Secondary general in 1995 to that in 1997?
Ensure brevity in your answer.  0.95. What is the ratio of the Number of enrolments of both sexes in Secondary vocational in 1995 to that in 1997?
Your response must be concise. 0.88. What is the ratio of the Number of enrolments of both sexes in Primary in 1996 to that in 1997?
Keep it short and to the point. 1. What is the ratio of the Number of enrolments of both sexes in Secondary in 1996 to that in 1997?
Offer a terse response. 0.98. What is the ratio of the Number of enrolments of both sexes in Secondary general in 1996 to that in 1997?
Offer a very short reply. 0.98. What is the ratio of the Number of enrolments of both sexes in Secondary vocational in 1996 to that in 1997?
Keep it short and to the point. 0.96. What is the difference between the highest and the second highest Number of enrolments of both sexes of Primary?
Ensure brevity in your answer.  23. What is the difference between the highest and the second highest Number of enrolments of both sexes of Secondary?
Offer a very short reply. 1421. What is the difference between the highest and the second highest Number of enrolments of both sexes of Secondary general?
Ensure brevity in your answer.  1217. What is the difference between the highest and the second highest Number of enrolments of both sexes of Secondary vocational?
Make the answer very short. 204. What is the difference between the highest and the lowest Number of enrolments of both sexes in Primary?
Your response must be concise. 1945. What is the difference between the highest and the lowest Number of enrolments of both sexes in Secondary?
Your answer should be very brief. 1.67e+04. What is the difference between the highest and the lowest Number of enrolments of both sexes in Secondary general?
Provide a short and direct response. 1.51e+04. What is the difference between the highest and the lowest Number of enrolments of both sexes of Secondary vocational?
Give a very brief answer. 1584. 